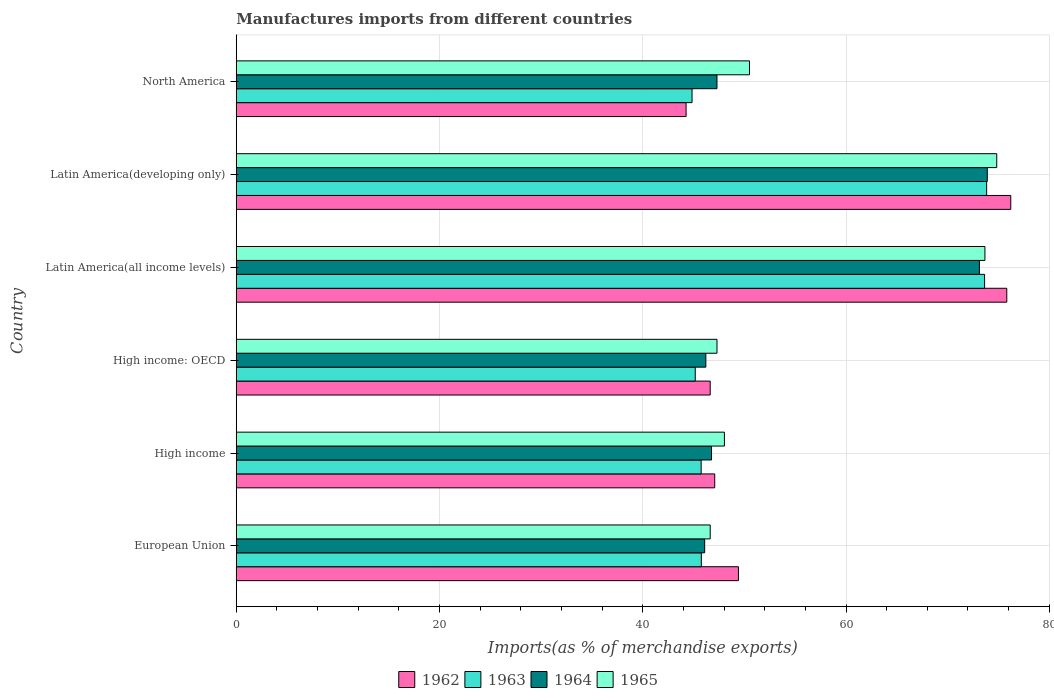How many bars are there on the 6th tick from the bottom?
Keep it short and to the point. 4. What is the percentage of imports to different countries in 1964 in North America?
Offer a very short reply. 47.3. Across all countries, what is the maximum percentage of imports to different countries in 1964?
Ensure brevity in your answer.  73.9. Across all countries, what is the minimum percentage of imports to different countries in 1963?
Your answer should be very brief. 44.85. In which country was the percentage of imports to different countries in 1962 maximum?
Offer a terse response. Latin America(developing only). In which country was the percentage of imports to different countries in 1962 minimum?
Make the answer very short. North America. What is the total percentage of imports to different countries in 1962 in the graph?
Ensure brevity in your answer.  339.42. What is the difference between the percentage of imports to different countries in 1962 in European Union and that in High income: OECD?
Keep it short and to the point. 2.78. What is the difference between the percentage of imports to different countries in 1962 in High income and the percentage of imports to different countries in 1963 in Latin America(developing only)?
Provide a short and direct response. -26.76. What is the average percentage of imports to different countries in 1962 per country?
Ensure brevity in your answer.  56.57. What is the difference between the percentage of imports to different countries in 1962 and percentage of imports to different countries in 1965 in Latin America(all income levels)?
Keep it short and to the point. 2.15. What is the ratio of the percentage of imports to different countries in 1964 in European Union to that in High income: OECD?
Keep it short and to the point. 1. Is the percentage of imports to different countries in 1965 in High income: OECD less than that in North America?
Your answer should be very brief. Yes. What is the difference between the highest and the second highest percentage of imports to different countries in 1964?
Your answer should be compact. 0.77. What is the difference between the highest and the lowest percentage of imports to different countries in 1962?
Your answer should be very brief. 31.95. In how many countries, is the percentage of imports to different countries in 1963 greater than the average percentage of imports to different countries in 1963 taken over all countries?
Provide a succinct answer. 2. Is the sum of the percentage of imports to different countries in 1965 in Latin America(all income levels) and Latin America(developing only) greater than the maximum percentage of imports to different countries in 1963 across all countries?
Your answer should be compact. Yes. What does the 4th bar from the bottom in Latin America(developing only) represents?
Your response must be concise. 1965. What is the difference between two consecutive major ticks on the X-axis?
Ensure brevity in your answer.  20. Does the graph contain any zero values?
Your answer should be very brief. No. Where does the legend appear in the graph?
Make the answer very short. Bottom center. How many legend labels are there?
Ensure brevity in your answer.  4. What is the title of the graph?
Provide a short and direct response. Manufactures imports from different countries. What is the label or title of the X-axis?
Provide a short and direct response. Imports(as % of merchandise exports). What is the label or title of the Y-axis?
Keep it short and to the point. Country. What is the Imports(as % of merchandise exports) of 1962 in European Union?
Your response must be concise. 49.41. What is the Imports(as % of merchandise exports) of 1963 in European Union?
Your answer should be compact. 45.76. What is the Imports(as % of merchandise exports) of 1964 in European Union?
Offer a very short reply. 46.09. What is the Imports(as % of merchandise exports) in 1965 in European Union?
Offer a very short reply. 46.64. What is the Imports(as % of merchandise exports) in 1962 in High income?
Provide a short and direct response. 47.08. What is the Imports(as % of merchandise exports) in 1963 in High income?
Give a very brief answer. 45.75. What is the Imports(as % of merchandise exports) of 1964 in High income?
Make the answer very short. 46.77. What is the Imports(as % of merchandise exports) of 1965 in High income?
Your answer should be very brief. 48.04. What is the Imports(as % of merchandise exports) in 1962 in High income: OECD?
Your answer should be very brief. 46.64. What is the Imports(as % of merchandise exports) of 1963 in High income: OECD?
Offer a terse response. 45.16. What is the Imports(as % of merchandise exports) in 1964 in High income: OECD?
Offer a terse response. 46.21. What is the Imports(as % of merchandise exports) in 1965 in High income: OECD?
Your answer should be very brief. 47.3. What is the Imports(as % of merchandise exports) in 1962 in Latin America(all income levels)?
Make the answer very short. 75.82. What is the Imports(as % of merchandise exports) of 1963 in Latin America(all income levels)?
Give a very brief answer. 73.64. What is the Imports(as % of merchandise exports) of 1964 in Latin America(all income levels)?
Offer a very short reply. 73.13. What is the Imports(as % of merchandise exports) of 1965 in Latin America(all income levels)?
Offer a terse response. 73.67. What is the Imports(as % of merchandise exports) of 1962 in Latin America(developing only)?
Give a very brief answer. 76.21. What is the Imports(as % of merchandise exports) in 1963 in Latin America(developing only)?
Ensure brevity in your answer.  73.84. What is the Imports(as % of merchandise exports) in 1964 in Latin America(developing only)?
Your answer should be compact. 73.9. What is the Imports(as % of merchandise exports) in 1965 in Latin America(developing only)?
Provide a short and direct response. 74.83. What is the Imports(as % of merchandise exports) in 1962 in North America?
Your response must be concise. 44.26. What is the Imports(as % of merchandise exports) of 1963 in North America?
Your answer should be compact. 44.85. What is the Imports(as % of merchandise exports) of 1964 in North America?
Make the answer very short. 47.3. What is the Imports(as % of merchandise exports) in 1965 in North America?
Ensure brevity in your answer.  50.5. Across all countries, what is the maximum Imports(as % of merchandise exports) of 1962?
Offer a terse response. 76.21. Across all countries, what is the maximum Imports(as % of merchandise exports) of 1963?
Offer a very short reply. 73.84. Across all countries, what is the maximum Imports(as % of merchandise exports) of 1964?
Keep it short and to the point. 73.9. Across all countries, what is the maximum Imports(as % of merchandise exports) of 1965?
Offer a terse response. 74.83. Across all countries, what is the minimum Imports(as % of merchandise exports) in 1962?
Offer a very short reply. 44.26. Across all countries, what is the minimum Imports(as % of merchandise exports) of 1963?
Offer a very short reply. 44.85. Across all countries, what is the minimum Imports(as % of merchandise exports) in 1964?
Provide a short and direct response. 46.09. Across all countries, what is the minimum Imports(as % of merchandise exports) of 1965?
Make the answer very short. 46.64. What is the total Imports(as % of merchandise exports) in 1962 in the graph?
Keep it short and to the point. 339.42. What is the total Imports(as % of merchandise exports) of 1963 in the graph?
Make the answer very short. 329. What is the total Imports(as % of merchandise exports) in 1964 in the graph?
Your response must be concise. 333.39. What is the total Imports(as % of merchandise exports) of 1965 in the graph?
Your answer should be compact. 340.98. What is the difference between the Imports(as % of merchandise exports) of 1962 in European Union and that in High income?
Give a very brief answer. 2.33. What is the difference between the Imports(as % of merchandise exports) in 1963 in European Union and that in High income?
Offer a very short reply. 0.02. What is the difference between the Imports(as % of merchandise exports) of 1964 in European Union and that in High income?
Keep it short and to the point. -0.68. What is the difference between the Imports(as % of merchandise exports) in 1965 in European Union and that in High income?
Your answer should be compact. -1.4. What is the difference between the Imports(as % of merchandise exports) in 1962 in European Union and that in High income: OECD?
Provide a short and direct response. 2.78. What is the difference between the Imports(as % of merchandise exports) of 1963 in European Union and that in High income: OECD?
Give a very brief answer. 0.6. What is the difference between the Imports(as % of merchandise exports) in 1964 in European Union and that in High income: OECD?
Provide a succinct answer. -0.12. What is the difference between the Imports(as % of merchandise exports) in 1965 in European Union and that in High income: OECD?
Ensure brevity in your answer.  -0.67. What is the difference between the Imports(as % of merchandise exports) of 1962 in European Union and that in Latin America(all income levels)?
Your answer should be very brief. -26.4. What is the difference between the Imports(as % of merchandise exports) in 1963 in European Union and that in Latin America(all income levels)?
Keep it short and to the point. -27.87. What is the difference between the Imports(as % of merchandise exports) in 1964 in European Union and that in Latin America(all income levels)?
Provide a short and direct response. -27.04. What is the difference between the Imports(as % of merchandise exports) of 1965 in European Union and that in Latin America(all income levels)?
Make the answer very short. -27.03. What is the difference between the Imports(as % of merchandise exports) in 1962 in European Union and that in Latin America(developing only)?
Make the answer very short. -26.8. What is the difference between the Imports(as % of merchandise exports) in 1963 in European Union and that in Latin America(developing only)?
Keep it short and to the point. -28.07. What is the difference between the Imports(as % of merchandise exports) in 1964 in European Union and that in Latin America(developing only)?
Provide a short and direct response. -27.81. What is the difference between the Imports(as % of merchandise exports) of 1965 in European Union and that in Latin America(developing only)?
Provide a short and direct response. -28.19. What is the difference between the Imports(as % of merchandise exports) in 1962 in European Union and that in North America?
Give a very brief answer. 5.15. What is the difference between the Imports(as % of merchandise exports) in 1963 in European Union and that in North America?
Offer a very short reply. 0.91. What is the difference between the Imports(as % of merchandise exports) of 1964 in European Union and that in North America?
Offer a terse response. -1.21. What is the difference between the Imports(as % of merchandise exports) in 1965 in European Union and that in North America?
Provide a succinct answer. -3.86. What is the difference between the Imports(as % of merchandise exports) of 1962 in High income and that in High income: OECD?
Your response must be concise. 0.44. What is the difference between the Imports(as % of merchandise exports) of 1963 in High income and that in High income: OECD?
Offer a very short reply. 0.58. What is the difference between the Imports(as % of merchandise exports) in 1964 in High income and that in High income: OECD?
Your response must be concise. 0.56. What is the difference between the Imports(as % of merchandise exports) in 1965 in High income and that in High income: OECD?
Make the answer very short. 0.73. What is the difference between the Imports(as % of merchandise exports) in 1962 in High income and that in Latin America(all income levels)?
Your response must be concise. -28.74. What is the difference between the Imports(as % of merchandise exports) in 1963 in High income and that in Latin America(all income levels)?
Make the answer very short. -27.89. What is the difference between the Imports(as % of merchandise exports) in 1964 in High income and that in Latin America(all income levels)?
Your answer should be compact. -26.36. What is the difference between the Imports(as % of merchandise exports) of 1965 in High income and that in Latin America(all income levels)?
Your answer should be very brief. -25.63. What is the difference between the Imports(as % of merchandise exports) of 1962 in High income and that in Latin America(developing only)?
Your answer should be compact. -29.13. What is the difference between the Imports(as % of merchandise exports) of 1963 in High income and that in Latin America(developing only)?
Offer a very short reply. -28.09. What is the difference between the Imports(as % of merchandise exports) in 1964 in High income and that in Latin America(developing only)?
Ensure brevity in your answer.  -27.13. What is the difference between the Imports(as % of merchandise exports) of 1965 in High income and that in Latin America(developing only)?
Your response must be concise. -26.8. What is the difference between the Imports(as % of merchandise exports) in 1962 in High income and that in North America?
Provide a short and direct response. 2.82. What is the difference between the Imports(as % of merchandise exports) in 1963 in High income and that in North America?
Your response must be concise. 0.9. What is the difference between the Imports(as % of merchandise exports) of 1964 in High income and that in North America?
Make the answer very short. -0.54. What is the difference between the Imports(as % of merchandise exports) of 1965 in High income and that in North America?
Give a very brief answer. -2.47. What is the difference between the Imports(as % of merchandise exports) in 1962 in High income: OECD and that in Latin America(all income levels)?
Your answer should be very brief. -29.18. What is the difference between the Imports(as % of merchandise exports) in 1963 in High income: OECD and that in Latin America(all income levels)?
Your answer should be very brief. -28.47. What is the difference between the Imports(as % of merchandise exports) of 1964 in High income: OECD and that in Latin America(all income levels)?
Your answer should be compact. -26.92. What is the difference between the Imports(as % of merchandise exports) of 1965 in High income: OECD and that in Latin America(all income levels)?
Your answer should be compact. -26.36. What is the difference between the Imports(as % of merchandise exports) in 1962 in High income: OECD and that in Latin America(developing only)?
Offer a terse response. -29.58. What is the difference between the Imports(as % of merchandise exports) in 1963 in High income: OECD and that in Latin America(developing only)?
Make the answer very short. -28.67. What is the difference between the Imports(as % of merchandise exports) of 1964 in High income: OECD and that in Latin America(developing only)?
Your answer should be very brief. -27.69. What is the difference between the Imports(as % of merchandise exports) of 1965 in High income: OECD and that in Latin America(developing only)?
Provide a short and direct response. -27.53. What is the difference between the Imports(as % of merchandise exports) of 1962 in High income: OECD and that in North America?
Your answer should be very brief. 2.37. What is the difference between the Imports(as % of merchandise exports) in 1963 in High income: OECD and that in North America?
Your answer should be very brief. 0.31. What is the difference between the Imports(as % of merchandise exports) of 1964 in High income: OECD and that in North America?
Offer a very short reply. -1.1. What is the difference between the Imports(as % of merchandise exports) in 1965 in High income: OECD and that in North America?
Provide a succinct answer. -3.2. What is the difference between the Imports(as % of merchandise exports) of 1962 in Latin America(all income levels) and that in Latin America(developing only)?
Your answer should be very brief. -0.39. What is the difference between the Imports(as % of merchandise exports) in 1963 in Latin America(all income levels) and that in Latin America(developing only)?
Your answer should be very brief. -0.2. What is the difference between the Imports(as % of merchandise exports) in 1964 in Latin America(all income levels) and that in Latin America(developing only)?
Keep it short and to the point. -0.77. What is the difference between the Imports(as % of merchandise exports) of 1965 in Latin America(all income levels) and that in Latin America(developing only)?
Your answer should be very brief. -1.16. What is the difference between the Imports(as % of merchandise exports) in 1962 in Latin America(all income levels) and that in North America?
Offer a very short reply. 31.56. What is the difference between the Imports(as % of merchandise exports) of 1963 in Latin America(all income levels) and that in North America?
Offer a terse response. 28.79. What is the difference between the Imports(as % of merchandise exports) of 1964 in Latin America(all income levels) and that in North America?
Your answer should be very brief. 25.82. What is the difference between the Imports(as % of merchandise exports) in 1965 in Latin America(all income levels) and that in North America?
Keep it short and to the point. 23.17. What is the difference between the Imports(as % of merchandise exports) of 1962 in Latin America(developing only) and that in North America?
Offer a terse response. 31.95. What is the difference between the Imports(as % of merchandise exports) in 1963 in Latin America(developing only) and that in North America?
Your answer should be compact. 28.99. What is the difference between the Imports(as % of merchandise exports) in 1964 in Latin America(developing only) and that in North America?
Offer a terse response. 26.6. What is the difference between the Imports(as % of merchandise exports) in 1965 in Latin America(developing only) and that in North America?
Your answer should be compact. 24.33. What is the difference between the Imports(as % of merchandise exports) in 1962 in European Union and the Imports(as % of merchandise exports) in 1963 in High income?
Provide a succinct answer. 3.67. What is the difference between the Imports(as % of merchandise exports) in 1962 in European Union and the Imports(as % of merchandise exports) in 1964 in High income?
Ensure brevity in your answer.  2.65. What is the difference between the Imports(as % of merchandise exports) of 1962 in European Union and the Imports(as % of merchandise exports) of 1965 in High income?
Provide a succinct answer. 1.38. What is the difference between the Imports(as % of merchandise exports) in 1963 in European Union and the Imports(as % of merchandise exports) in 1964 in High income?
Offer a terse response. -1. What is the difference between the Imports(as % of merchandise exports) in 1963 in European Union and the Imports(as % of merchandise exports) in 1965 in High income?
Provide a succinct answer. -2.27. What is the difference between the Imports(as % of merchandise exports) in 1964 in European Union and the Imports(as % of merchandise exports) in 1965 in High income?
Your answer should be very brief. -1.94. What is the difference between the Imports(as % of merchandise exports) of 1962 in European Union and the Imports(as % of merchandise exports) of 1963 in High income: OECD?
Keep it short and to the point. 4.25. What is the difference between the Imports(as % of merchandise exports) in 1962 in European Union and the Imports(as % of merchandise exports) in 1964 in High income: OECD?
Provide a succinct answer. 3.21. What is the difference between the Imports(as % of merchandise exports) in 1962 in European Union and the Imports(as % of merchandise exports) in 1965 in High income: OECD?
Ensure brevity in your answer.  2.11. What is the difference between the Imports(as % of merchandise exports) of 1963 in European Union and the Imports(as % of merchandise exports) of 1964 in High income: OECD?
Offer a terse response. -0.44. What is the difference between the Imports(as % of merchandise exports) of 1963 in European Union and the Imports(as % of merchandise exports) of 1965 in High income: OECD?
Ensure brevity in your answer.  -1.54. What is the difference between the Imports(as % of merchandise exports) of 1964 in European Union and the Imports(as % of merchandise exports) of 1965 in High income: OECD?
Offer a terse response. -1.21. What is the difference between the Imports(as % of merchandise exports) in 1962 in European Union and the Imports(as % of merchandise exports) in 1963 in Latin America(all income levels)?
Your answer should be compact. -24.22. What is the difference between the Imports(as % of merchandise exports) of 1962 in European Union and the Imports(as % of merchandise exports) of 1964 in Latin America(all income levels)?
Ensure brevity in your answer.  -23.71. What is the difference between the Imports(as % of merchandise exports) in 1962 in European Union and the Imports(as % of merchandise exports) in 1965 in Latin America(all income levels)?
Give a very brief answer. -24.25. What is the difference between the Imports(as % of merchandise exports) in 1963 in European Union and the Imports(as % of merchandise exports) in 1964 in Latin America(all income levels)?
Your answer should be very brief. -27.36. What is the difference between the Imports(as % of merchandise exports) in 1963 in European Union and the Imports(as % of merchandise exports) in 1965 in Latin America(all income levels)?
Provide a succinct answer. -27.91. What is the difference between the Imports(as % of merchandise exports) of 1964 in European Union and the Imports(as % of merchandise exports) of 1965 in Latin America(all income levels)?
Your answer should be very brief. -27.58. What is the difference between the Imports(as % of merchandise exports) in 1962 in European Union and the Imports(as % of merchandise exports) in 1963 in Latin America(developing only)?
Offer a terse response. -24.42. What is the difference between the Imports(as % of merchandise exports) in 1962 in European Union and the Imports(as % of merchandise exports) in 1964 in Latin America(developing only)?
Ensure brevity in your answer.  -24.49. What is the difference between the Imports(as % of merchandise exports) of 1962 in European Union and the Imports(as % of merchandise exports) of 1965 in Latin America(developing only)?
Make the answer very short. -25.42. What is the difference between the Imports(as % of merchandise exports) of 1963 in European Union and the Imports(as % of merchandise exports) of 1964 in Latin America(developing only)?
Give a very brief answer. -28.14. What is the difference between the Imports(as % of merchandise exports) in 1963 in European Union and the Imports(as % of merchandise exports) in 1965 in Latin America(developing only)?
Make the answer very short. -29.07. What is the difference between the Imports(as % of merchandise exports) of 1964 in European Union and the Imports(as % of merchandise exports) of 1965 in Latin America(developing only)?
Ensure brevity in your answer.  -28.74. What is the difference between the Imports(as % of merchandise exports) in 1962 in European Union and the Imports(as % of merchandise exports) in 1963 in North America?
Offer a very short reply. 4.56. What is the difference between the Imports(as % of merchandise exports) in 1962 in European Union and the Imports(as % of merchandise exports) in 1964 in North America?
Offer a terse response. 2.11. What is the difference between the Imports(as % of merchandise exports) of 1962 in European Union and the Imports(as % of merchandise exports) of 1965 in North America?
Provide a short and direct response. -1.09. What is the difference between the Imports(as % of merchandise exports) of 1963 in European Union and the Imports(as % of merchandise exports) of 1964 in North America?
Your answer should be compact. -1.54. What is the difference between the Imports(as % of merchandise exports) of 1963 in European Union and the Imports(as % of merchandise exports) of 1965 in North America?
Your response must be concise. -4.74. What is the difference between the Imports(as % of merchandise exports) of 1964 in European Union and the Imports(as % of merchandise exports) of 1965 in North America?
Offer a very short reply. -4.41. What is the difference between the Imports(as % of merchandise exports) of 1962 in High income and the Imports(as % of merchandise exports) of 1963 in High income: OECD?
Keep it short and to the point. 1.92. What is the difference between the Imports(as % of merchandise exports) in 1962 in High income and the Imports(as % of merchandise exports) in 1964 in High income: OECD?
Keep it short and to the point. 0.87. What is the difference between the Imports(as % of merchandise exports) in 1962 in High income and the Imports(as % of merchandise exports) in 1965 in High income: OECD?
Your answer should be compact. -0.22. What is the difference between the Imports(as % of merchandise exports) of 1963 in High income and the Imports(as % of merchandise exports) of 1964 in High income: OECD?
Your response must be concise. -0.46. What is the difference between the Imports(as % of merchandise exports) of 1963 in High income and the Imports(as % of merchandise exports) of 1965 in High income: OECD?
Ensure brevity in your answer.  -1.56. What is the difference between the Imports(as % of merchandise exports) of 1964 in High income and the Imports(as % of merchandise exports) of 1965 in High income: OECD?
Keep it short and to the point. -0.54. What is the difference between the Imports(as % of merchandise exports) of 1962 in High income and the Imports(as % of merchandise exports) of 1963 in Latin America(all income levels)?
Offer a very short reply. -26.56. What is the difference between the Imports(as % of merchandise exports) in 1962 in High income and the Imports(as % of merchandise exports) in 1964 in Latin America(all income levels)?
Ensure brevity in your answer.  -26.05. What is the difference between the Imports(as % of merchandise exports) of 1962 in High income and the Imports(as % of merchandise exports) of 1965 in Latin America(all income levels)?
Keep it short and to the point. -26.59. What is the difference between the Imports(as % of merchandise exports) of 1963 in High income and the Imports(as % of merchandise exports) of 1964 in Latin America(all income levels)?
Your answer should be compact. -27.38. What is the difference between the Imports(as % of merchandise exports) of 1963 in High income and the Imports(as % of merchandise exports) of 1965 in Latin America(all income levels)?
Your response must be concise. -27.92. What is the difference between the Imports(as % of merchandise exports) in 1964 in High income and the Imports(as % of merchandise exports) in 1965 in Latin America(all income levels)?
Provide a short and direct response. -26.9. What is the difference between the Imports(as % of merchandise exports) of 1962 in High income and the Imports(as % of merchandise exports) of 1963 in Latin America(developing only)?
Your answer should be compact. -26.76. What is the difference between the Imports(as % of merchandise exports) in 1962 in High income and the Imports(as % of merchandise exports) in 1964 in Latin America(developing only)?
Your answer should be very brief. -26.82. What is the difference between the Imports(as % of merchandise exports) of 1962 in High income and the Imports(as % of merchandise exports) of 1965 in Latin America(developing only)?
Give a very brief answer. -27.75. What is the difference between the Imports(as % of merchandise exports) of 1963 in High income and the Imports(as % of merchandise exports) of 1964 in Latin America(developing only)?
Make the answer very short. -28.15. What is the difference between the Imports(as % of merchandise exports) of 1963 in High income and the Imports(as % of merchandise exports) of 1965 in Latin America(developing only)?
Make the answer very short. -29.09. What is the difference between the Imports(as % of merchandise exports) of 1964 in High income and the Imports(as % of merchandise exports) of 1965 in Latin America(developing only)?
Your answer should be compact. -28.07. What is the difference between the Imports(as % of merchandise exports) in 1962 in High income and the Imports(as % of merchandise exports) in 1963 in North America?
Your answer should be compact. 2.23. What is the difference between the Imports(as % of merchandise exports) in 1962 in High income and the Imports(as % of merchandise exports) in 1964 in North America?
Provide a succinct answer. -0.22. What is the difference between the Imports(as % of merchandise exports) of 1962 in High income and the Imports(as % of merchandise exports) of 1965 in North America?
Give a very brief answer. -3.42. What is the difference between the Imports(as % of merchandise exports) of 1963 in High income and the Imports(as % of merchandise exports) of 1964 in North America?
Keep it short and to the point. -1.56. What is the difference between the Imports(as % of merchandise exports) in 1963 in High income and the Imports(as % of merchandise exports) in 1965 in North America?
Your response must be concise. -4.76. What is the difference between the Imports(as % of merchandise exports) of 1964 in High income and the Imports(as % of merchandise exports) of 1965 in North America?
Provide a short and direct response. -3.74. What is the difference between the Imports(as % of merchandise exports) of 1962 in High income: OECD and the Imports(as % of merchandise exports) of 1963 in Latin America(all income levels)?
Make the answer very short. -27. What is the difference between the Imports(as % of merchandise exports) in 1962 in High income: OECD and the Imports(as % of merchandise exports) in 1964 in Latin America(all income levels)?
Offer a very short reply. -26.49. What is the difference between the Imports(as % of merchandise exports) in 1962 in High income: OECD and the Imports(as % of merchandise exports) in 1965 in Latin America(all income levels)?
Your response must be concise. -27.03. What is the difference between the Imports(as % of merchandise exports) of 1963 in High income: OECD and the Imports(as % of merchandise exports) of 1964 in Latin America(all income levels)?
Your answer should be compact. -27.96. What is the difference between the Imports(as % of merchandise exports) in 1963 in High income: OECD and the Imports(as % of merchandise exports) in 1965 in Latin America(all income levels)?
Offer a terse response. -28.5. What is the difference between the Imports(as % of merchandise exports) of 1964 in High income: OECD and the Imports(as % of merchandise exports) of 1965 in Latin America(all income levels)?
Provide a succinct answer. -27.46. What is the difference between the Imports(as % of merchandise exports) of 1962 in High income: OECD and the Imports(as % of merchandise exports) of 1963 in Latin America(developing only)?
Make the answer very short. -27.2. What is the difference between the Imports(as % of merchandise exports) in 1962 in High income: OECD and the Imports(as % of merchandise exports) in 1964 in Latin America(developing only)?
Provide a short and direct response. -27.26. What is the difference between the Imports(as % of merchandise exports) in 1962 in High income: OECD and the Imports(as % of merchandise exports) in 1965 in Latin America(developing only)?
Provide a succinct answer. -28.2. What is the difference between the Imports(as % of merchandise exports) in 1963 in High income: OECD and the Imports(as % of merchandise exports) in 1964 in Latin America(developing only)?
Provide a succinct answer. -28.74. What is the difference between the Imports(as % of merchandise exports) in 1963 in High income: OECD and the Imports(as % of merchandise exports) in 1965 in Latin America(developing only)?
Give a very brief answer. -29.67. What is the difference between the Imports(as % of merchandise exports) of 1964 in High income: OECD and the Imports(as % of merchandise exports) of 1965 in Latin America(developing only)?
Your answer should be compact. -28.62. What is the difference between the Imports(as % of merchandise exports) of 1962 in High income: OECD and the Imports(as % of merchandise exports) of 1963 in North America?
Your response must be concise. 1.79. What is the difference between the Imports(as % of merchandise exports) of 1962 in High income: OECD and the Imports(as % of merchandise exports) of 1964 in North America?
Give a very brief answer. -0.67. What is the difference between the Imports(as % of merchandise exports) in 1962 in High income: OECD and the Imports(as % of merchandise exports) in 1965 in North America?
Provide a succinct answer. -3.87. What is the difference between the Imports(as % of merchandise exports) in 1963 in High income: OECD and the Imports(as % of merchandise exports) in 1964 in North America?
Provide a succinct answer. -2.14. What is the difference between the Imports(as % of merchandise exports) of 1963 in High income: OECD and the Imports(as % of merchandise exports) of 1965 in North America?
Give a very brief answer. -5.34. What is the difference between the Imports(as % of merchandise exports) in 1964 in High income: OECD and the Imports(as % of merchandise exports) in 1965 in North America?
Ensure brevity in your answer.  -4.29. What is the difference between the Imports(as % of merchandise exports) in 1962 in Latin America(all income levels) and the Imports(as % of merchandise exports) in 1963 in Latin America(developing only)?
Ensure brevity in your answer.  1.98. What is the difference between the Imports(as % of merchandise exports) of 1962 in Latin America(all income levels) and the Imports(as % of merchandise exports) of 1964 in Latin America(developing only)?
Provide a short and direct response. 1.92. What is the difference between the Imports(as % of merchandise exports) of 1962 in Latin America(all income levels) and the Imports(as % of merchandise exports) of 1965 in Latin America(developing only)?
Give a very brief answer. 0.99. What is the difference between the Imports(as % of merchandise exports) in 1963 in Latin America(all income levels) and the Imports(as % of merchandise exports) in 1964 in Latin America(developing only)?
Your response must be concise. -0.26. What is the difference between the Imports(as % of merchandise exports) in 1963 in Latin America(all income levels) and the Imports(as % of merchandise exports) in 1965 in Latin America(developing only)?
Provide a short and direct response. -1.2. What is the difference between the Imports(as % of merchandise exports) in 1964 in Latin America(all income levels) and the Imports(as % of merchandise exports) in 1965 in Latin America(developing only)?
Your response must be concise. -1.71. What is the difference between the Imports(as % of merchandise exports) in 1962 in Latin America(all income levels) and the Imports(as % of merchandise exports) in 1963 in North America?
Offer a terse response. 30.97. What is the difference between the Imports(as % of merchandise exports) of 1962 in Latin America(all income levels) and the Imports(as % of merchandise exports) of 1964 in North America?
Offer a very short reply. 28.51. What is the difference between the Imports(as % of merchandise exports) in 1962 in Latin America(all income levels) and the Imports(as % of merchandise exports) in 1965 in North America?
Provide a short and direct response. 25.32. What is the difference between the Imports(as % of merchandise exports) in 1963 in Latin America(all income levels) and the Imports(as % of merchandise exports) in 1964 in North America?
Your answer should be compact. 26.33. What is the difference between the Imports(as % of merchandise exports) in 1963 in Latin America(all income levels) and the Imports(as % of merchandise exports) in 1965 in North America?
Give a very brief answer. 23.13. What is the difference between the Imports(as % of merchandise exports) of 1964 in Latin America(all income levels) and the Imports(as % of merchandise exports) of 1965 in North America?
Ensure brevity in your answer.  22.62. What is the difference between the Imports(as % of merchandise exports) of 1962 in Latin America(developing only) and the Imports(as % of merchandise exports) of 1963 in North America?
Provide a succinct answer. 31.36. What is the difference between the Imports(as % of merchandise exports) in 1962 in Latin America(developing only) and the Imports(as % of merchandise exports) in 1964 in North America?
Your response must be concise. 28.91. What is the difference between the Imports(as % of merchandise exports) of 1962 in Latin America(developing only) and the Imports(as % of merchandise exports) of 1965 in North America?
Ensure brevity in your answer.  25.71. What is the difference between the Imports(as % of merchandise exports) of 1963 in Latin America(developing only) and the Imports(as % of merchandise exports) of 1964 in North America?
Offer a terse response. 26.53. What is the difference between the Imports(as % of merchandise exports) of 1963 in Latin America(developing only) and the Imports(as % of merchandise exports) of 1965 in North America?
Ensure brevity in your answer.  23.34. What is the difference between the Imports(as % of merchandise exports) in 1964 in Latin America(developing only) and the Imports(as % of merchandise exports) in 1965 in North America?
Provide a succinct answer. 23.4. What is the average Imports(as % of merchandise exports) of 1962 per country?
Your response must be concise. 56.57. What is the average Imports(as % of merchandise exports) of 1963 per country?
Your answer should be very brief. 54.83. What is the average Imports(as % of merchandise exports) of 1964 per country?
Offer a very short reply. 55.57. What is the average Imports(as % of merchandise exports) in 1965 per country?
Keep it short and to the point. 56.83. What is the difference between the Imports(as % of merchandise exports) of 1962 and Imports(as % of merchandise exports) of 1963 in European Union?
Provide a succinct answer. 3.65. What is the difference between the Imports(as % of merchandise exports) in 1962 and Imports(as % of merchandise exports) in 1964 in European Union?
Your response must be concise. 3.32. What is the difference between the Imports(as % of merchandise exports) of 1962 and Imports(as % of merchandise exports) of 1965 in European Union?
Offer a very short reply. 2.78. What is the difference between the Imports(as % of merchandise exports) of 1963 and Imports(as % of merchandise exports) of 1964 in European Union?
Keep it short and to the point. -0.33. What is the difference between the Imports(as % of merchandise exports) in 1963 and Imports(as % of merchandise exports) in 1965 in European Union?
Your answer should be compact. -0.88. What is the difference between the Imports(as % of merchandise exports) in 1964 and Imports(as % of merchandise exports) in 1965 in European Union?
Offer a very short reply. -0.55. What is the difference between the Imports(as % of merchandise exports) of 1962 and Imports(as % of merchandise exports) of 1963 in High income?
Your answer should be compact. 1.33. What is the difference between the Imports(as % of merchandise exports) of 1962 and Imports(as % of merchandise exports) of 1964 in High income?
Ensure brevity in your answer.  0.31. What is the difference between the Imports(as % of merchandise exports) in 1962 and Imports(as % of merchandise exports) in 1965 in High income?
Offer a terse response. -0.96. What is the difference between the Imports(as % of merchandise exports) in 1963 and Imports(as % of merchandise exports) in 1964 in High income?
Keep it short and to the point. -1.02. What is the difference between the Imports(as % of merchandise exports) of 1963 and Imports(as % of merchandise exports) of 1965 in High income?
Keep it short and to the point. -2.29. What is the difference between the Imports(as % of merchandise exports) in 1964 and Imports(as % of merchandise exports) in 1965 in High income?
Offer a very short reply. -1.27. What is the difference between the Imports(as % of merchandise exports) in 1962 and Imports(as % of merchandise exports) in 1963 in High income: OECD?
Provide a short and direct response. 1.47. What is the difference between the Imports(as % of merchandise exports) in 1962 and Imports(as % of merchandise exports) in 1964 in High income: OECD?
Ensure brevity in your answer.  0.43. What is the difference between the Imports(as % of merchandise exports) of 1962 and Imports(as % of merchandise exports) of 1965 in High income: OECD?
Keep it short and to the point. -0.67. What is the difference between the Imports(as % of merchandise exports) of 1963 and Imports(as % of merchandise exports) of 1964 in High income: OECD?
Your answer should be compact. -1.04. What is the difference between the Imports(as % of merchandise exports) in 1963 and Imports(as % of merchandise exports) in 1965 in High income: OECD?
Your answer should be compact. -2.14. What is the difference between the Imports(as % of merchandise exports) in 1964 and Imports(as % of merchandise exports) in 1965 in High income: OECD?
Your response must be concise. -1.1. What is the difference between the Imports(as % of merchandise exports) of 1962 and Imports(as % of merchandise exports) of 1963 in Latin America(all income levels)?
Ensure brevity in your answer.  2.18. What is the difference between the Imports(as % of merchandise exports) in 1962 and Imports(as % of merchandise exports) in 1964 in Latin America(all income levels)?
Provide a short and direct response. 2.69. What is the difference between the Imports(as % of merchandise exports) of 1962 and Imports(as % of merchandise exports) of 1965 in Latin America(all income levels)?
Keep it short and to the point. 2.15. What is the difference between the Imports(as % of merchandise exports) of 1963 and Imports(as % of merchandise exports) of 1964 in Latin America(all income levels)?
Offer a terse response. 0.51. What is the difference between the Imports(as % of merchandise exports) in 1963 and Imports(as % of merchandise exports) in 1965 in Latin America(all income levels)?
Offer a very short reply. -0.03. What is the difference between the Imports(as % of merchandise exports) of 1964 and Imports(as % of merchandise exports) of 1965 in Latin America(all income levels)?
Offer a terse response. -0.54. What is the difference between the Imports(as % of merchandise exports) of 1962 and Imports(as % of merchandise exports) of 1963 in Latin America(developing only)?
Your answer should be compact. 2.37. What is the difference between the Imports(as % of merchandise exports) in 1962 and Imports(as % of merchandise exports) in 1964 in Latin America(developing only)?
Your answer should be compact. 2.31. What is the difference between the Imports(as % of merchandise exports) in 1962 and Imports(as % of merchandise exports) in 1965 in Latin America(developing only)?
Make the answer very short. 1.38. What is the difference between the Imports(as % of merchandise exports) of 1963 and Imports(as % of merchandise exports) of 1964 in Latin America(developing only)?
Provide a short and direct response. -0.06. What is the difference between the Imports(as % of merchandise exports) in 1963 and Imports(as % of merchandise exports) in 1965 in Latin America(developing only)?
Keep it short and to the point. -0.99. What is the difference between the Imports(as % of merchandise exports) of 1964 and Imports(as % of merchandise exports) of 1965 in Latin America(developing only)?
Provide a succinct answer. -0.93. What is the difference between the Imports(as % of merchandise exports) of 1962 and Imports(as % of merchandise exports) of 1963 in North America?
Provide a succinct answer. -0.59. What is the difference between the Imports(as % of merchandise exports) of 1962 and Imports(as % of merchandise exports) of 1964 in North America?
Your answer should be compact. -3.04. What is the difference between the Imports(as % of merchandise exports) in 1962 and Imports(as % of merchandise exports) in 1965 in North America?
Provide a succinct answer. -6.24. What is the difference between the Imports(as % of merchandise exports) of 1963 and Imports(as % of merchandise exports) of 1964 in North America?
Give a very brief answer. -2.45. What is the difference between the Imports(as % of merchandise exports) in 1963 and Imports(as % of merchandise exports) in 1965 in North America?
Provide a succinct answer. -5.65. What is the difference between the Imports(as % of merchandise exports) of 1964 and Imports(as % of merchandise exports) of 1965 in North America?
Provide a short and direct response. -3.2. What is the ratio of the Imports(as % of merchandise exports) of 1962 in European Union to that in High income?
Your answer should be compact. 1.05. What is the ratio of the Imports(as % of merchandise exports) of 1963 in European Union to that in High income?
Provide a short and direct response. 1. What is the ratio of the Imports(as % of merchandise exports) in 1964 in European Union to that in High income?
Give a very brief answer. 0.99. What is the ratio of the Imports(as % of merchandise exports) in 1965 in European Union to that in High income?
Offer a terse response. 0.97. What is the ratio of the Imports(as % of merchandise exports) of 1962 in European Union to that in High income: OECD?
Give a very brief answer. 1.06. What is the ratio of the Imports(as % of merchandise exports) in 1963 in European Union to that in High income: OECD?
Ensure brevity in your answer.  1.01. What is the ratio of the Imports(as % of merchandise exports) in 1964 in European Union to that in High income: OECD?
Provide a short and direct response. 1. What is the ratio of the Imports(as % of merchandise exports) in 1965 in European Union to that in High income: OECD?
Offer a terse response. 0.99. What is the ratio of the Imports(as % of merchandise exports) of 1962 in European Union to that in Latin America(all income levels)?
Keep it short and to the point. 0.65. What is the ratio of the Imports(as % of merchandise exports) in 1963 in European Union to that in Latin America(all income levels)?
Offer a terse response. 0.62. What is the ratio of the Imports(as % of merchandise exports) in 1964 in European Union to that in Latin America(all income levels)?
Give a very brief answer. 0.63. What is the ratio of the Imports(as % of merchandise exports) in 1965 in European Union to that in Latin America(all income levels)?
Provide a succinct answer. 0.63. What is the ratio of the Imports(as % of merchandise exports) of 1962 in European Union to that in Latin America(developing only)?
Provide a succinct answer. 0.65. What is the ratio of the Imports(as % of merchandise exports) of 1963 in European Union to that in Latin America(developing only)?
Make the answer very short. 0.62. What is the ratio of the Imports(as % of merchandise exports) in 1964 in European Union to that in Latin America(developing only)?
Provide a succinct answer. 0.62. What is the ratio of the Imports(as % of merchandise exports) of 1965 in European Union to that in Latin America(developing only)?
Make the answer very short. 0.62. What is the ratio of the Imports(as % of merchandise exports) of 1962 in European Union to that in North America?
Keep it short and to the point. 1.12. What is the ratio of the Imports(as % of merchandise exports) of 1963 in European Union to that in North America?
Provide a succinct answer. 1.02. What is the ratio of the Imports(as % of merchandise exports) of 1964 in European Union to that in North America?
Your response must be concise. 0.97. What is the ratio of the Imports(as % of merchandise exports) of 1965 in European Union to that in North America?
Offer a very short reply. 0.92. What is the ratio of the Imports(as % of merchandise exports) in 1962 in High income to that in High income: OECD?
Offer a terse response. 1.01. What is the ratio of the Imports(as % of merchandise exports) of 1963 in High income to that in High income: OECD?
Provide a short and direct response. 1.01. What is the ratio of the Imports(as % of merchandise exports) in 1964 in High income to that in High income: OECD?
Your response must be concise. 1.01. What is the ratio of the Imports(as % of merchandise exports) in 1965 in High income to that in High income: OECD?
Make the answer very short. 1.02. What is the ratio of the Imports(as % of merchandise exports) of 1962 in High income to that in Latin America(all income levels)?
Offer a terse response. 0.62. What is the ratio of the Imports(as % of merchandise exports) of 1963 in High income to that in Latin America(all income levels)?
Your answer should be very brief. 0.62. What is the ratio of the Imports(as % of merchandise exports) in 1964 in High income to that in Latin America(all income levels)?
Your answer should be very brief. 0.64. What is the ratio of the Imports(as % of merchandise exports) of 1965 in High income to that in Latin America(all income levels)?
Provide a short and direct response. 0.65. What is the ratio of the Imports(as % of merchandise exports) in 1962 in High income to that in Latin America(developing only)?
Offer a terse response. 0.62. What is the ratio of the Imports(as % of merchandise exports) of 1963 in High income to that in Latin America(developing only)?
Your answer should be compact. 0.62. What is the ratio of the Imports(as % of merchandise exports) of 1964 in High income to that in Latin America(developing only)?
Offer a terse response. 0.63. What is the ratio of the Imports(as % of merchandise exports) in 1965 in High income to that in Latin America(developing only)?
Ensure brevity in your answer.  0.64. What is the ratio of the Imports(as % of merchandise exports) of 1962 in High income to that in North America?
Your response must be concise. 1.06. What is the ratio of the Imports(as % of merchandise exports) in 1964 in High income to that in North America?
Your answer should be very brief. 0.99. What is the ratio of the Imports(as % of merchandise exports) in 1965 in High income to that in North America?
Your response must be concise. 0.95. What is the ratio of the Imports(as % of merchandise exports) in 1962 in High income: OECD to that in Latin America(all income levels)?
Your response must be concise. 0.62. What is the ratio of the Imports(as % of merchandise exports) of 1963 in High income: OECD to that in Latin America(all income levels)?
Make the answer very short. 0.61. What is the ratio of the Imports(as % of merchandise exports) of 1964 in High income: OECD to that in Latin America(all income levels)?
Provide a succinct answer. 0.63. What is the ratio of the Imports(as % of merchandise exports) of 1965 in High income: OECD to that in Latin America(all income levels)?
Your answer should be compact. 0.64. What is the ratio of the Imports(as % of merchandise exports) in 1962 in High income: OECD to that in Latin America(developing only)?
Keep it short and to the point. 0.61. What is the ratio of the Imports(as % of merchandise exports) in 1963 in High income: OECD to that in Latin America(developing only)?
Your answer should be very brief. 0.61. What is the ratio of the Imports(as % of merchandise exports) in 1964 in High income: OECD to that in Latin America(developing only)?
Make the answer very short. 0.63. What is the ratio of the Imports(as % of merchandise exports) in 1965 in High income: OECD to that in Latin America(developing only)?
Keep it short and to the point. 0.63. What is the ratio of the Imports(as % of merchandise exports) in 1962 in High income: OECD to that in North America?
Provide a succinct answer. 1.05. What is the ratio of the Imports(as % of merchandise exports) in 1963 in High income: OECD to that in North America?
Your answer should be compact. 1.01. What is the ratio of the Imports(as % of merchandise exports) of 1964 in High income: OECD to that in North America?
Your answer should be compact. 0.98. What is the ratio of the Imports(as % of merchandise exports) in 1965 in High income: OECD to that in North America?
Offer a very short reply. 0.94. What is the ratio of the Imports(as % of merchandise exports) of 1964 in Latin America(all income levels) to that in Latin America(developing only)?
Keep it short and to the point. 0.99. What is the ratio of the Imports(as % of merchandise exports) in 1965 in Latin America(all income levels) to that in Latin America(developing only)?
Give a very brief answer. 0.98. What is the ratio of the Imports(as % of merchandise exports) of 1962 in Latin America(all income levels) to that in North America?
Your answer should be compact. 1.71. What is the ratio of the Imports(as % of merchandise exports) of 1963 in Latin America(all income levels) to that in North America?
Your answer should be very brief. 1.64. What is the ratio of the Imports(as % of merchandise exports) of 1964 in Latin America(all income levels) to that in North America?
Make the answer very short. 1.55. What is the ratio of the Imports(as % of merchandise exports) of 1965 in Latin America(all income levels) to that in North America?
Your answer should be very brief. 1.46. What is the ratio of the Imports(as % of merchandise exports) of 1962 in Latin America(developing only) to that in North America?
Make the answer very short. 1.72. What is the ratio of the Imports(as % of merchandise exports) of 1963 in Latin America(developing only) to that in North America?
Offer a terse response. 1.65. What is the ratio of the Imports(as % of merchandise exports) of 1964 in Latin America(developing only) to that in North America?
Offer a very short reply. 1.56. What is the ratio of the Imports(as % of merchandise exports) in 1965 in Latin America(developing only) to that in North America?
Your response must be concise. 1.48. What is the difference between the highest and the second highest Imports(as % of merchandise exports) in 1962?
Keep it short and to the point. 0.39. What is the difference between the highest and the second highest Imports(as % of merchandise exports) of 1963?
Your answer should be very brief. 0.2. What is the difference between the highest and the second highest Imports(as % of merchandise exports) of 1964?
Keep it short and to the point. 0.77. What is the difference between the highest and the second highest Imports(as % of merchandise exports) in 1965?
Provide a succinct answer. 1.16. What is the difference between the highest and the lowest Imports(as % of merchandise exports) in 1962?
Give a very brief answer. 31.95. What is the difference between the highest and the lowest Imports(as % of merchandise exports) of 1963?
Provide a succinct answer. 28.99. What is the difference between the highest and the lowest Imports(as % of merchandise exports) in 1964?
Offer a very short reply. 27.81. What is the difference between the highest and the lowest Imports(as % of merchandise exports) in 1965?
Your response must be concise. 28.19. 